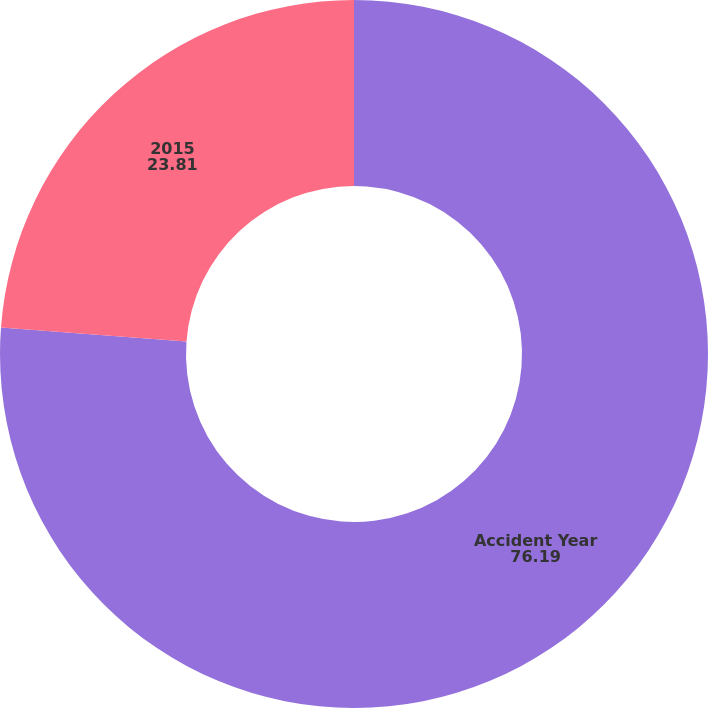Convert chart. <chart><loc_0><loc_0><loc_500><loc_500><pie_chart><fcel>Accident Year<fcel>2015<nl><fcel>76.19%<fcel>23.81%<nl></chart> 